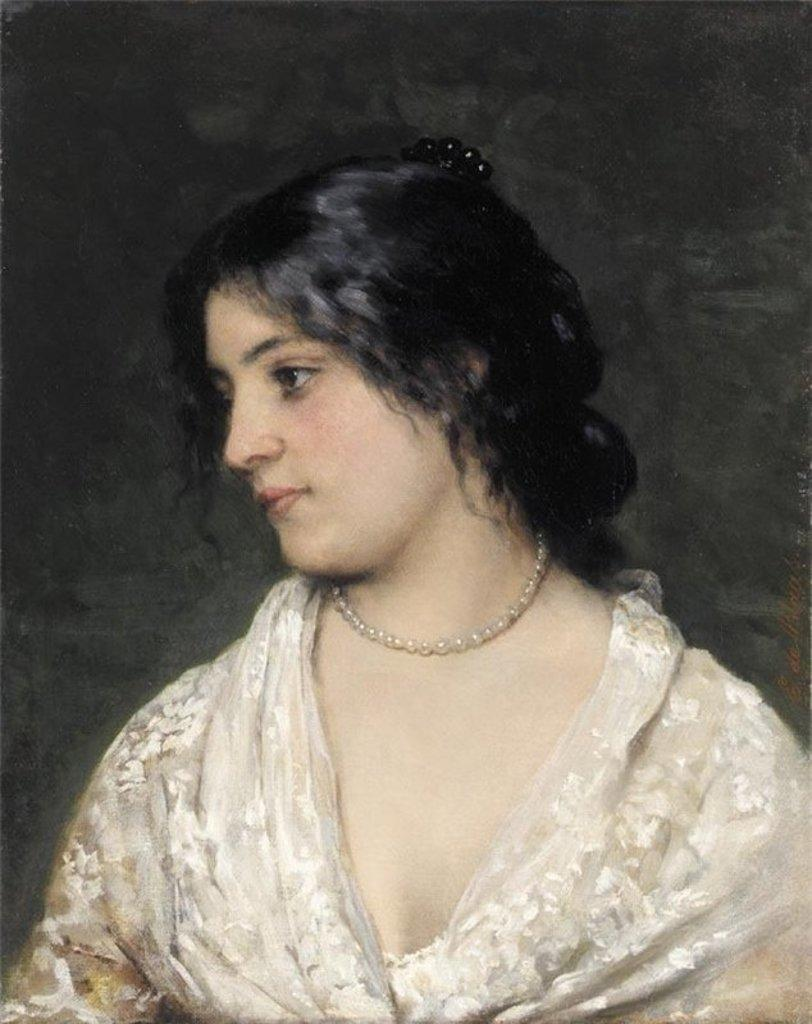What is the main subject of the image? There is a painting in the image. What is depicted in the painting? The painting depicts a lady. What accessory is the lady wearing in the painting? The lady is wearing a pearl chain. What type of trousers is the lady wearing in the painting? The lady in the painting is not wearing trousers; she is depicted in a way that does not include trousers. Can you hear any thunder in the image? There is no sound or audible element in the image, so it is not possible to hear thunder. 